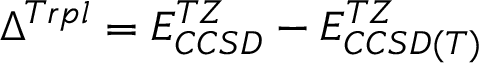<formula> <loc_0><loc_0><loc_500><loc_500>\Delta ^ { T r p l } = E _ { C C S D } ^ { T Z } - E _ { C C S D ( T ) } ^ { T Z }</formula> 